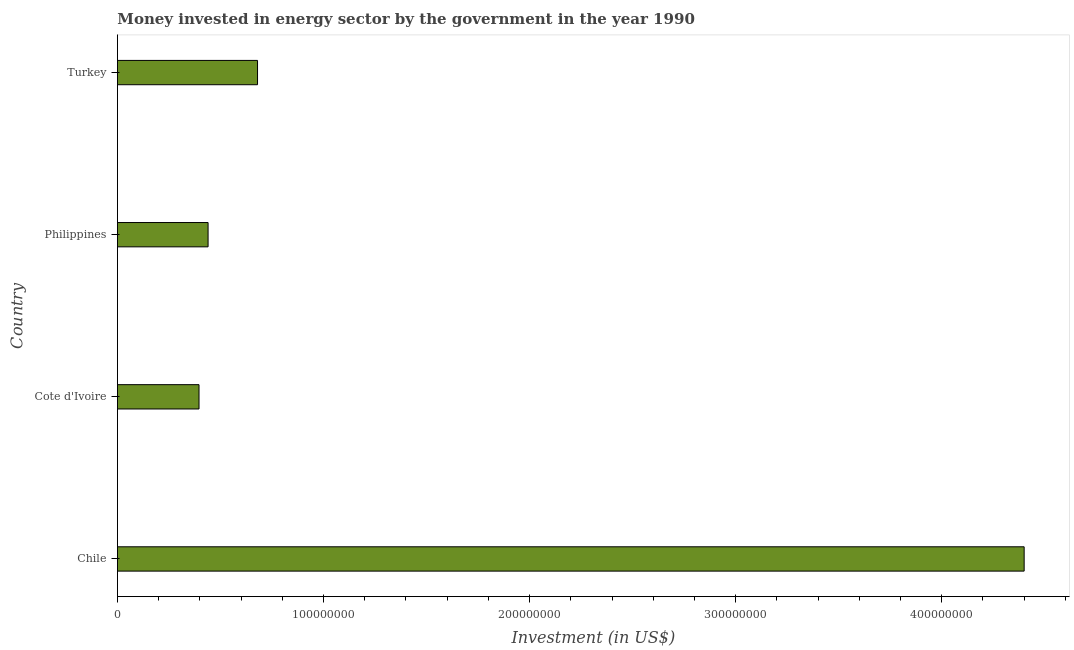Does the graph contain any zero values?
Your answer should be very brief. No. What is the title of the graph?
Keep it short and to the point. Money invested in energy sector by the government in the year 1990. What is the label or title of the X-axis?
Make the answer very short. Investment (in US$). What is the investment in energy in Philippines?
Your response must be concise. 4.40e+07. Across all countries, what is the maximum investment in energy?
Your answer should be compact. 4.40e+08. Across all countries, what is the minimum investment in energy?
Make the answer very short. 3.96e+07. In which country was the investment in energy minimum?
Your answer should be very brief. Cote d'Ivoire. What is the sum of the investment in energy?
Make the answer very short. 5.92e+08. What is the difference between the investment in energy in Chile and Cote d'Ivoire?
Keep it short and to the point. 4.00e+08. What is the average investment in energy per country?
Provide a short and direct response. 1.48e+08. What is the median investment in energy?
Keep it short and to the point. 5.60e+07. What is the ratio of the investment in energy in Chile to that in Philippines?
Ensure brevity in your answer.  10. Is the difference between the investment in energy in Chile and Cote d'Ivoire greater than the difference between any two countries?
Make the answer very short. Yes. What is the difference between the highest and the second highest investment in energy?
Your answer should be compact. 3.72e+08. Is the sum of the investment in energy in Cote d'Ivoire and Turkey greater than the maximum investment in energy across all countries?
Your answer should be compact. No. What is the difference between the highest and the lowest investment in energy?
Give a very brief answer. 4.00e+08. How many bars are there?
Your answer should be compact. 4. Are all the bars in the graph horizontal?
Your answer should be very brief. Yes. How many countries are there in the graph?
Offer a terse response. 4. What is the difference between two consecutive major ticks on the X-axis?
Your response must be concise. 1.00e+08. Are the values on the major ticks of X-axis written in scientific E-notation?
Keep it short and to the point. No. What is the Investment (in US$) in Chile?
Keep it short and to the point. 4.40e+08. What is the Investment (in US$) in Cote d'Ivoire?
Provide a short and direct response. 3.96e+07. What is the Investment (in US$) in Philippines?
Provide a succinct answer. 4.40e+07. What is the Investment (in US$) of Turkey?
Offer a terse response. 6.80e+07. What is the difference between the Investment (in US$) in Chile and Cote d'Ivoire?
Ensure brevity in your answer.  4.00e+08. What is the difference between the Investment (in US$) in Chile and Philippines?
Offer a very short reply. 3.96e+08. What is the difference between the Investment (in US$) in Chile and Turkey?
Give a very brief answer. 3.72e+08. What is the difference between the Investment (in US$) in Cote d'Ivoire and Philippines?
Provide a short and direct response. -4.40e+06. What is the difference between the Investment (in US$) in Cote d'Ivoire and Turkey?
Your response must be concise. -2.84e+07. What is the difference between the Investment (in US$) in Philippines and Turkey?
Provide a succinct answer. -2.40e+07. What is the ratio of the Investment (in US$) in Chile to that in Cote d'Ivoire?
Offer a terse response. 11.11. What is the ratio of the Investment (in US$) in Chile to that in Turkey?
Provide a short and direct response. 6.47. What is the ratio of the Investment (in US$) in Cote d'Ivoire to that in Turkey?
Your response must be concise. 0.58. What is the ratio of the Investment (in US$) in Philippines to that in Turkey?
Your answer should be very brief. 0.65. 